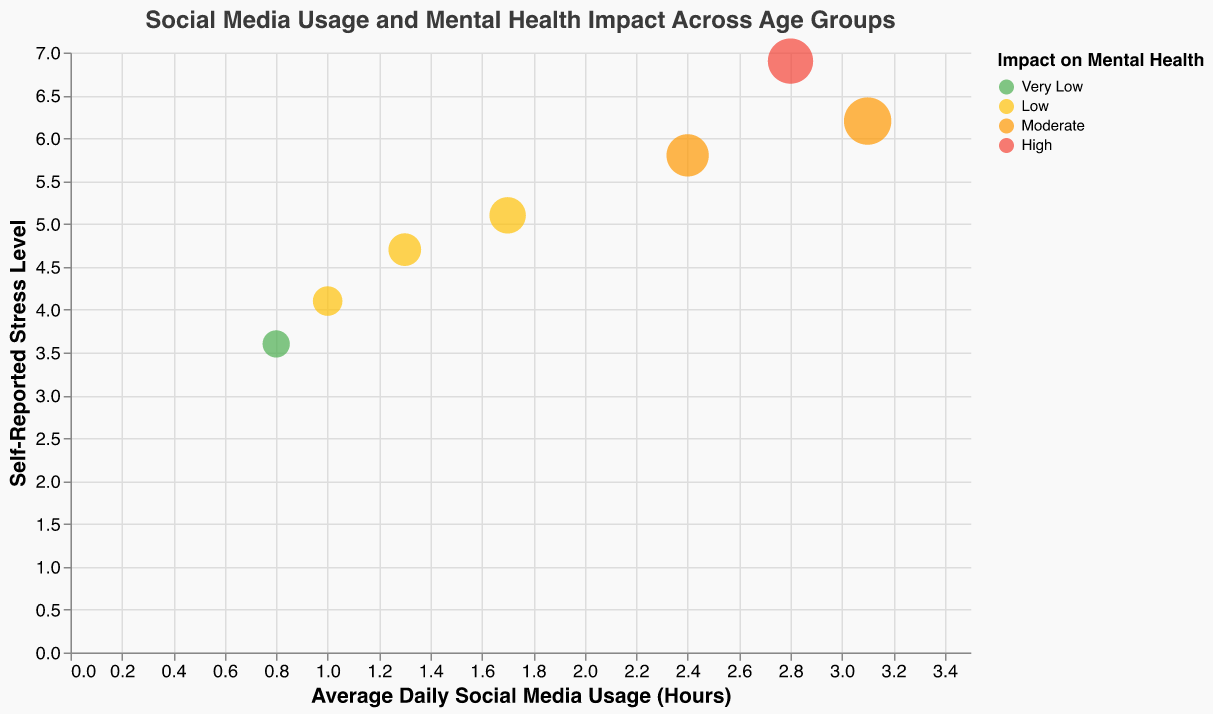what is the title of the chart? The title of the chart is usually displayed at the top center of the figure. In this figure, the title reads "Social Media Usage and Mental Health Impact Across Age Groups".
Answer: Social Media Usage and Mental Health Impact Across Age Groups How many age groups are represented in the chart? To find the total number of age groups, look at how many distinct bubbles (or tooltip entries) are displayed. Each bubble corresponds to one age group in this chart. There are seven unique age groups listed.
Answer: 7 Which age group reports the lowest level of stress? To determine this, locate the bubble with the lowest value on the y-axis labeled "Self-Reported Stress Level". The bubble for the 65+ age group is mapped to the lowest y-axis value of 3.6, making it the lowest stress level reported.
Answer: 65+ Which group has the highest daily social media usage? To find the group with the highest usage, identify the bubble farthest along the x-axis labeled "Average Daily Social Media Usage (Hours)." The 13-18 age group, at an x-value of 3.1, has the highest daily social media usage.
Answer: 13-18 What overall trend can be observed between daily social media usage and self-reported stress levels across age groups? To understand the overall trend, notice how the bubbles' positions change along the x-axis and y-axis. Generally, higher average daily social media usage corresponds to higher self-reported stress levels, illustrating a positive correlation between social media usage and stress.
Answer: Positive correlation Which age group has a Moderate impact on mental health and what is their daily social media usage? Identify bubbles color-coded as "Moderate" in orange. From the tooltips, both age groups 13-18 and 25-34 have a Moderate impact on mental health, with the 13-18 group reporting 3.1 hours and the 25-34 group reporting 2.4 hours of daily social media usage.
Answer: Age groups 13-18 (3.1 hours) and 25-34 (2.4 hours) What is the difference in daily social media usage between the groups reporting High impact and Moderate impact on mental health? The group with High impact (19-24) has 2.8 hours of usage and the groups with Moderate impact (13-18 and 25-34) have 3.1 and 2.4 hours respectively. Taking the highest value for Moderates (3.1) and subtracting the High value (2.8), the difference is 0.3 hours.
Answer: 0.3 hours How does the bubble size vary across the chart? The bubble size represents the daily social media usage and is scaled proportionately. Larger bubbles signify higher daily social media usage. Smaller bubbles are found with age groups indicating lower usage such as the 65+ group (0.8 hours), while larger bubbles represent younger age groups like 13-18 with highest usage (3.1 hours).
Answer: Varies with social media usage Among age groups with a Low impact on mental health, which group reports the highest stress level? Check bubbles color-coded in yellow that represent Low impact on mental health and compare their y-axis values. The age group 35-44 reports the highest stress level among these groups with a value of 5.1.
Answer: 35-44 How might removing social media impact mental health in the 19-24 age group based on stress levels in other age groups? The 19-24 age group reports a high impact on mental health with high stress levels (6.9) and relatively high social media usage (2.8 hours). Observing older age groups (35+), who report lower usage and lower stress, implies that reducing social media might reduce stress and improve mental health. However, individual psychological factors should also be considered beyond just usage stats.
Answer: Reducing social media might reduce stress 